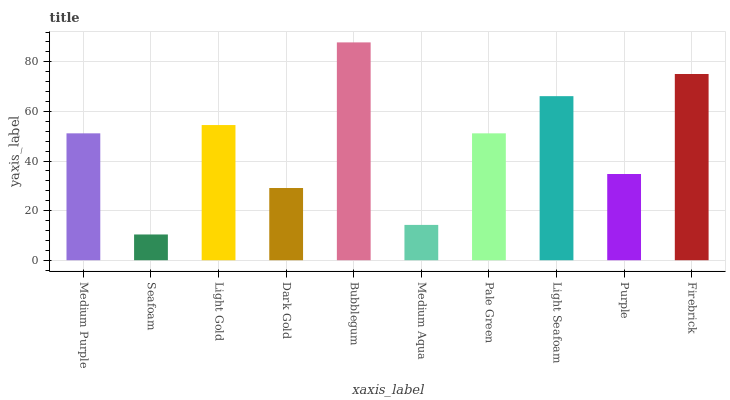Is Seafoam the minimum?
Answer yes or no. Yes. Is Bubblegum the maximum?
Answer yes or no. Yes. Is Light Gold the minimum?
Answer yes or no. No. Is Light Gold the maximum?
Answer yes or no. No. Is Light Gold greater than Seafoam?
Answer yes or no. Yes. Is Seafoam less than Light Gold?
Answer yes or no. Yes. Is Seafoam greater than Light Gold?
Answer yes or no. No. Is Light Gold less than Seafoam?
Answer yes or no. No. Is Medium Purple the high median?
Answer yes or no. Yes. Is Pale Green the low median?
Answer yes or no. Yes. Is Medium Aqua the high median?
Answer yes or no. No. Is Dark Gold the low median?
Answer yes or no. No. 